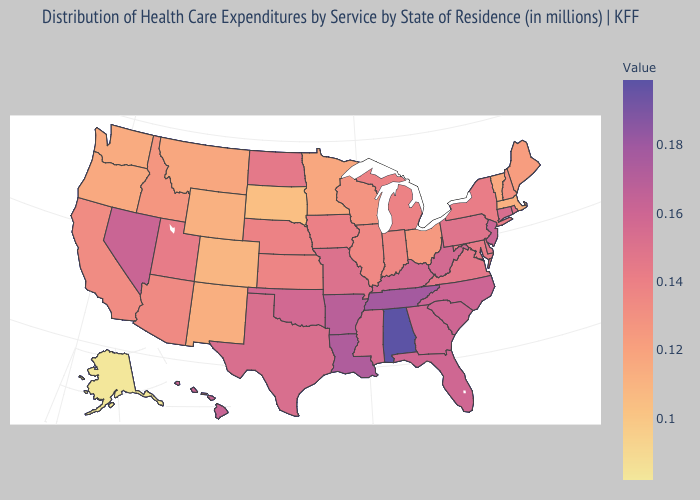Does Pennsylvania have the lowest value in the USA?
Give a very brief answer. No. Does the map have missing data?
Short answer required. No. Does Alabama have the highest value in the South?
Quick response, please. Yes. Which states have the lowest value in the USA?
Be succinct. Alaska. Among the states that border Arkansas , which have the lowest value?
Give a very brief answer. Missouri. Which states hav the highest value in the MidWest?
Give a very brief answer. Missouri. 